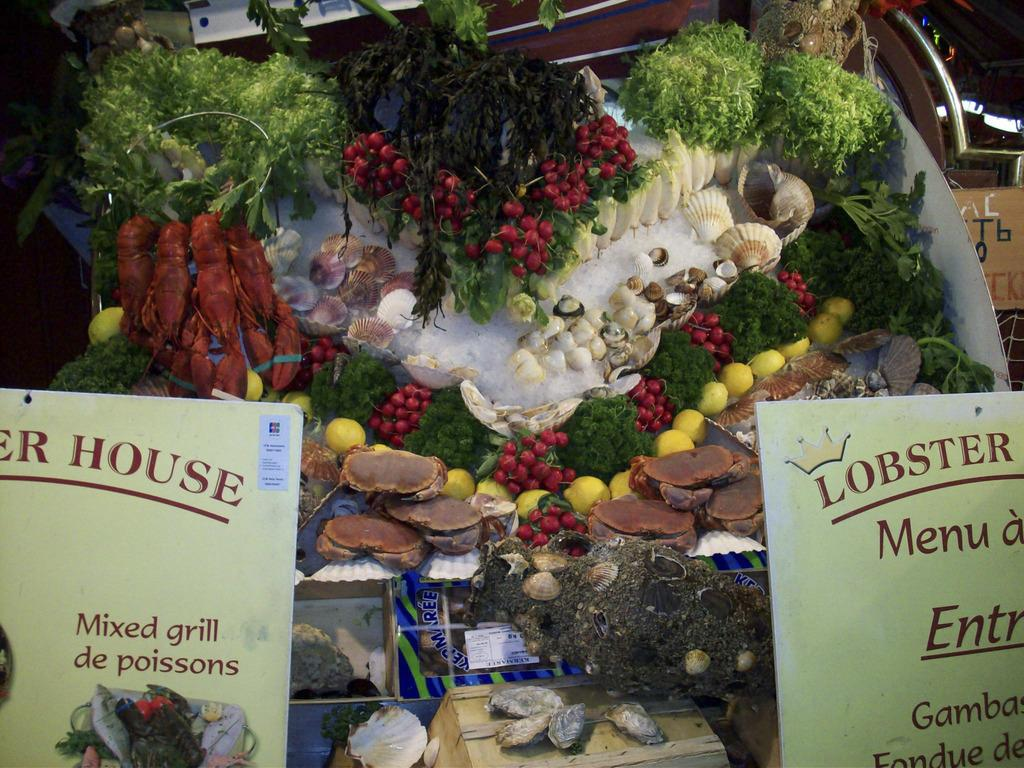What can be seen on the boards in the image? There are boards in the image with writing on them. What is visible in the background of the image? In the background of the image, there are shells, fruits, and other green things. What type of food is being served for dinner in the image? There is no dinner or food present in the image; it only features boards with writing, shells, fruits, and other green things in the background. 